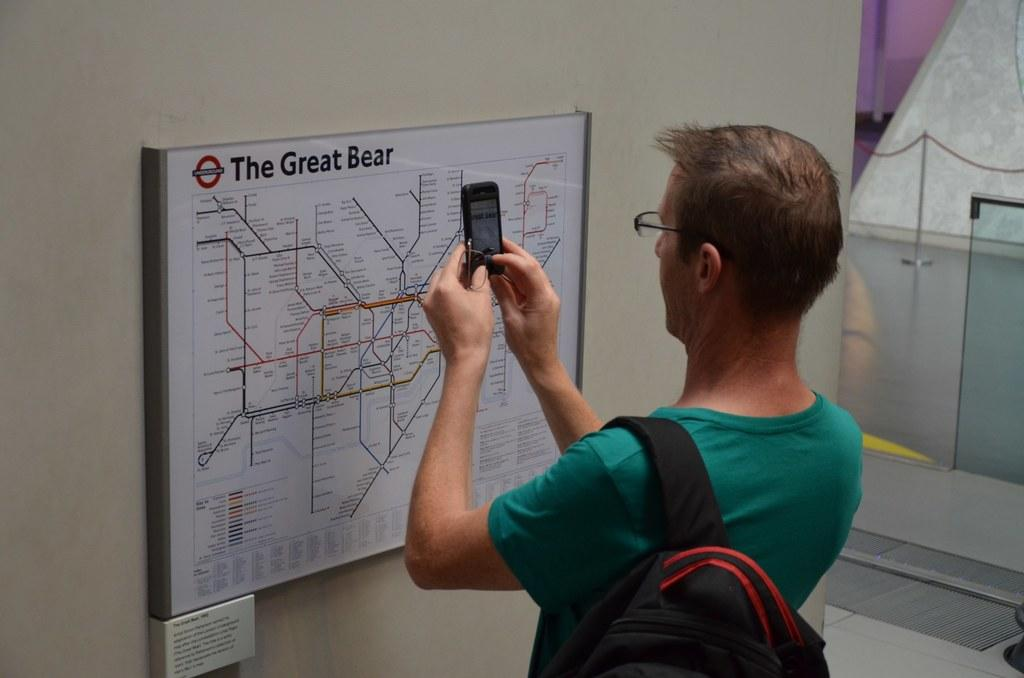<image>
Share a concise interpretation of the image provided. A man takes a picture of a map of The Great Bear. 